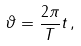Convert formula to latex. <formula><loc_0><loc_0><loc_500><loc_500>\vartheta = \frac { 2 \pi } { T } t \, ,</formula> 